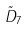<formula> <loc_0><loc_0><loc_500><loc_500>\tilde { D } _ { 7 }</formula> 